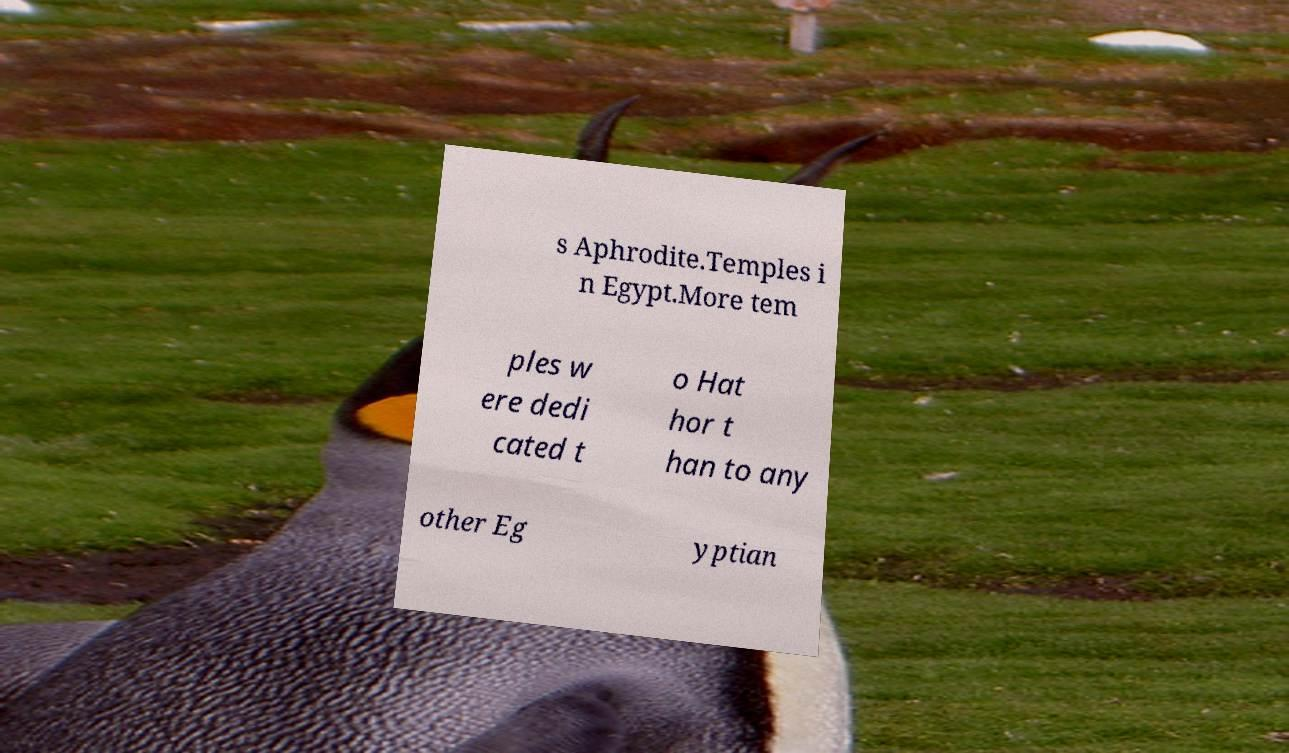I need the written content from this picture converted into text. Can you do that? s Aphrodite.Temples i n Egypt.More tem ples w ere dedi cated t o Hat hor t han to any other Eg yptian 